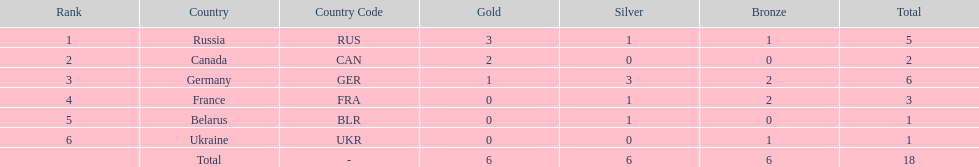Who had a larger total medal count, france or canada? France. 